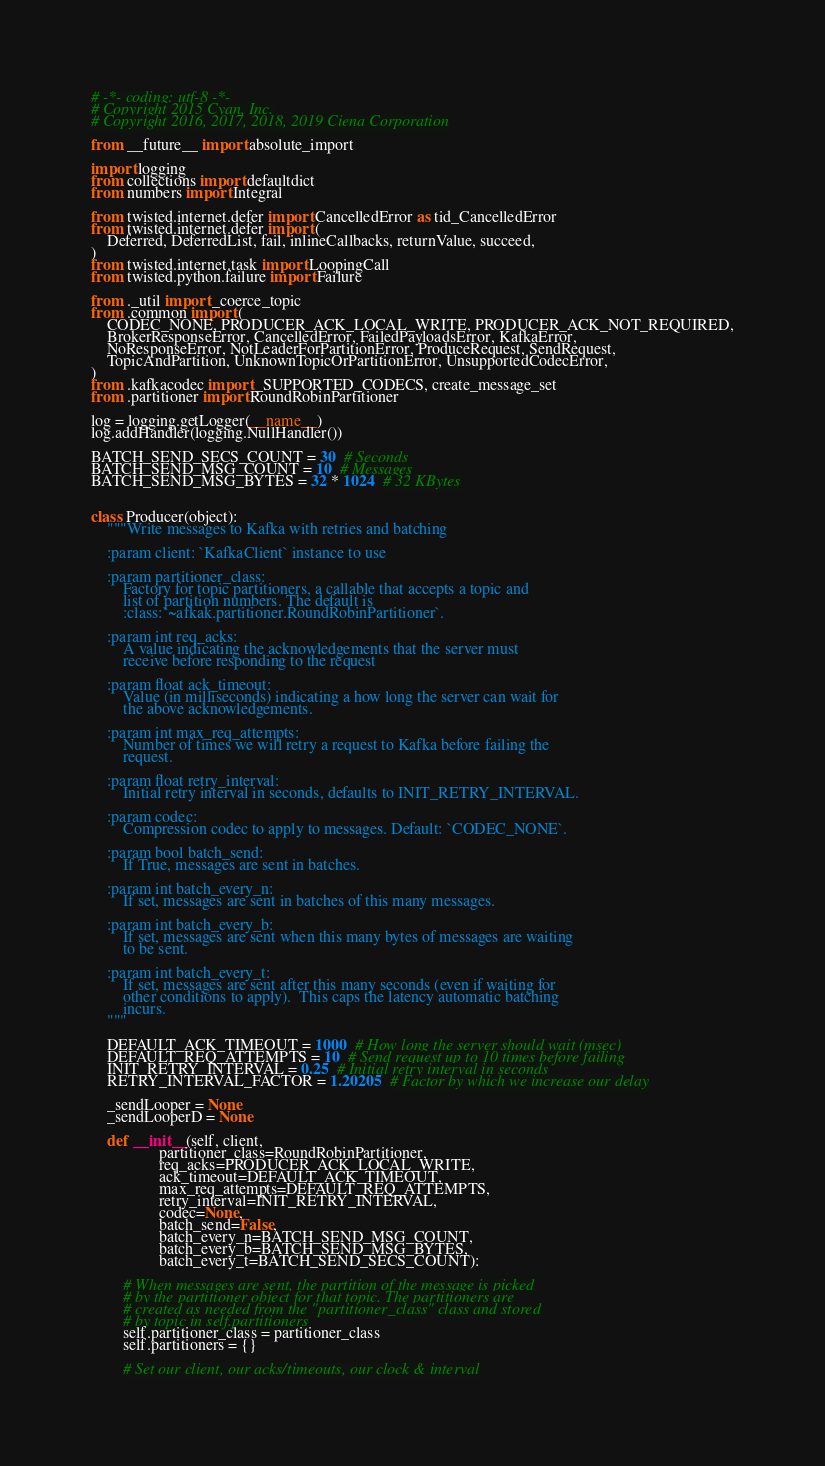Convert code to text. <code><loc_0><loc_0><loc_500><loc_500><_Python_># -*- coding: utf-8 -*-
# Copyright 2015 Cyan, Inc.
# Copyright 2016, 2017, 2018, 2019 Ciena Corporation

from __future__ import absolute_import

import logging
from collections import defaultdict
from numbers import Integral

from twisted.internet.defer import CancelledError as tid_CancelledError
from twisted.internet.defer import (
    Deferred, DeferredList, fail, inlineCallbacks, returnValue, succeed,
)
from twisted.internet.task import LoopingCall
from twisted.python.failure import Failure

from ._util import _coerce_topic
from .common import (
    CODEC_NONE, PRODUCER_ACK_LOCAL_WRITE, PRODUCER_ACK_NOT_REQUIRED,
    BrokerResponseError, CancelledError, FailedPayloadsError, KafkaError,
    NoResponseError, NotLeaderForPartitionError, ProduceRequest, SendRequest,
    TopicAndPartition, UnknownTopicOrPartitionError, UnsupportedCodecError,
)
from .kafkacodec import _SUPPORTED_CODECS, create_message_set
from .partitioner import RoundRobinPartitioner

log = logging.getLogger(__name__)
log.addHandler(logging.NullHandler())

BATCH_SEND_SECS_COUNT = 30  # Seconds
BATCH_SEND_MSG_COUNT = 10  # Messages
BATCH_SEND_MSG_BYTES = 32 * 1024  # 32 KBytes


class Producer(object):
    """Write messages to Kafka with retries and batching

    :param client: `KafkaClient` instance to use

    :param partitioner_class:
        Factory for topic partitioners, a callable that accepts a topic and
        list of partition numbers. The default is
        :class:`~afkak.partitioner.RoundRobinPartitioner`.

    :param int req_acks:
        A value indicating the acknowledgements that the server must
        receive before responding to the request

    :param float ack_timeout:
        Value (in milliseconds) indicating a how long the server can wait for
        the above acknowledgements.

    :param int max_req_attempts:
        Number of times we will retry a request to Kafka before failing the
        request.

    :param float retry_interval:
        Initial retry interval in seconds, defaults to INIT_RETRY_INTERVAL.

    :param codec:
        Compression codec to apply to messages. Default: `CODEC_NONE`.

    :param bool batch_send:
        If True, messages are sent in batches.

    :param int batch_every_n:
        If set, messages are sent in batches of this many messages.

    :param int batch_every_b:
        If set, messages are sent when this many bytes of messages are waiting
        to be sent.

    :param int batch_every_t:
        If set, messages are sent after this many seconds (even if waiting for
        other conditions to apply).  This caps the latency automatic batching
        incurs.
    """

    DEFAULT_ACK_TIMEOUT = 1000  # How long the server should wait (msec)
    DEFAULT_REQ_ATTEMPTS = 10  # Send request up to 10 times before failing
    INIT_RETRY_INTERVAL = 0.25  # Initial retry interval in seconds
    RETRY_INTERVAL_FACTOR = 1.20205  # Factor by which we increase our delay

    _sendLooper = None
    _sendLooperD = None

    def __init__(self, client,
                 partitioner_class=RoundRobinPartitioner,
                 req_acks=PRODUCER_ACK_LOCAL_WRITE,
                 ack_timeout=DEFAULT_ACK_TIMEOUT,
                 max_req_attempts=DEFAULT_REQ_ATTEMPTS,
                 retry_interval=INIT_RETRY_INTERVAL,
                 codec=None,
                 batch_send=False,
                 batch_every_n=BATCH_SEND_MSG_COUNT,
                 batch_every_b=BATCH_SEND_MSG_BYTES,
                 batch_every_t=BATCH_SEND_SECS_COUNT):

        # When messages are sent, the partition of the message is picked
        # by the partitioner object for that topic. The partitioners are
        # created as needed from the "partitioner_class" class and stored
        # by topic in self.partitioners
        self.partitioner_class = partitioner_class
        self.partitioners = {}

        # Set our client, our acks/timeouts, our clock & interval</code> 